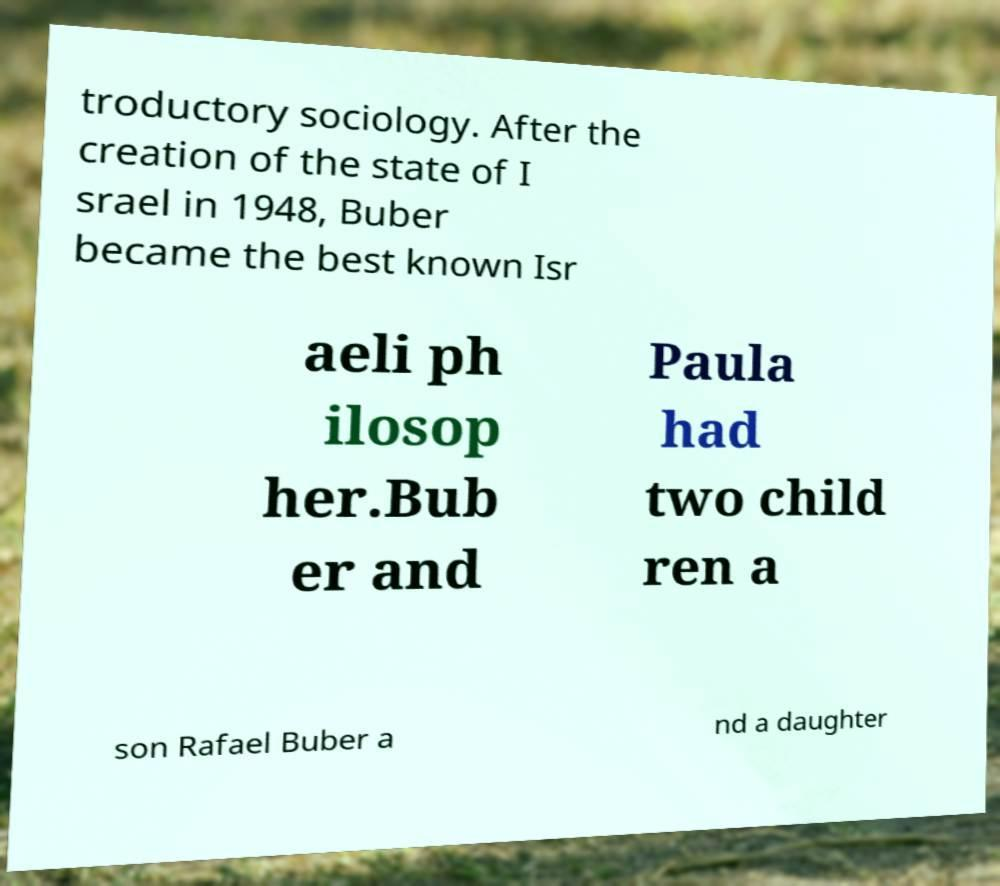Can you accurately transcribe the text from the provided image for me? troductory sociology. After the creation of the state of I srael in 1948, Buber became the best known Isr aeli ph ilosop her.Bub er and Paula had two child ren a son Rafael Buber a nd a daughter 